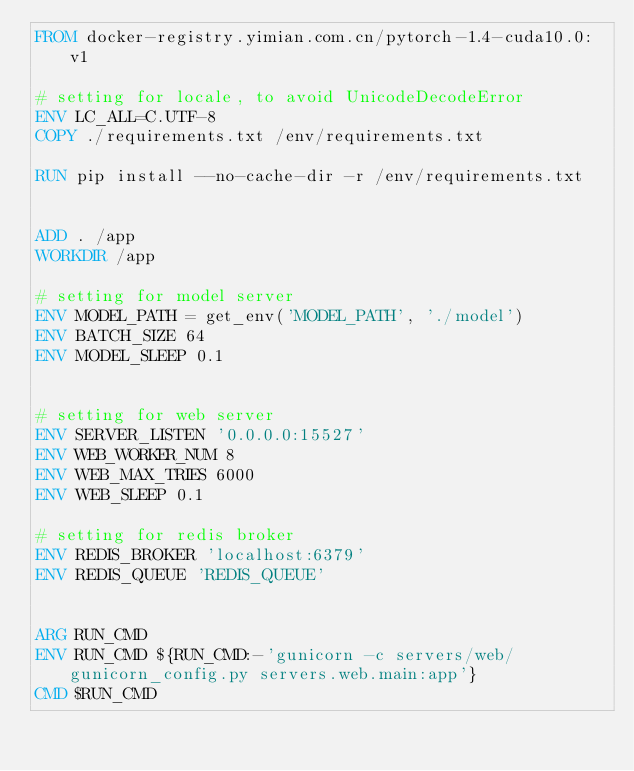<code> <loc_0><loc_0><loc_500><loc_500><_Dockerfile_>FROM docker-registry.yimian.com.cn/pytorch-1.4-cuda10.0:v1

# setting for locale, to avoid UnicodeDecodeError
ENV LC_ALL=C.UTF-8
COPY ./requirements.txt /env/requirements.txt

RUN pip install --no-cache-dir -r /env/requirements.txt


ADD . /app
WORKDIR /app

# setting for model server
ENV MODEL_PATH = get_env('MODEL_PATH', './model')
ENV BATCH_SIZE 64
ENV MODEL_SLEEP 0.1


# setting for web server
ENV SERVER_LISTEN '0.0.0.0:15527'
ENV WEB_WORKER_NUM 8
ENV WEB_MAX_TRIES 6000
ENV WEB_SLEEP 0.1

# setting for redis broker
ENV REDIS_BROKER 'localhost:6379'
ENV REDIS_QUEUE 'REDIS_QUEUE'


ARG RUN_CMD
ENV RUN_CMD ${RUN_CMD:-'gunicorn -c servers/web/gunicorn_config.py servers.web.main:app'}
CMD $RUN_CMD</code> 